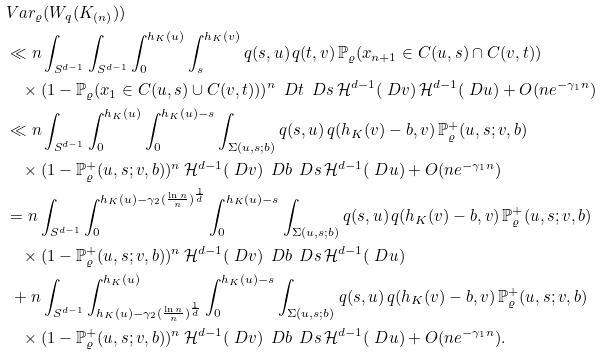<formula> <loc_0><loc_0><loc_500><loc_500>& \ V a r _ { \varrho } ( W _ { q } ( K _ { ( n ) } ) ) \\ & \ \ll n \int _ { S ^ { d - 1 } } \int _ { S ^ { d - 1 } } \int _ { 0 } ^ { h _ { K } ( u ) } \int _ { s } ^ { h _ { K } ( v ) } q ( s , u ) \, q ( t , v ) \, \mathbb { P } _ { \varrho } ( x _ { n + 1 } \in C ( u , s ) \cap C ( v , t ) ) \\ & \ \quad \times ( 1 - \mathbb { P } _ { \varrho } ( x _ { 1 } \in C ( u , s ) \cup C ( v , t ) ) ) ^ { n } \, \ D t \, \ D s \, \mathcal { H } ^ { d - 1 } ( \ D v ) \, \mathcal { H } ^ { d - 1 } ( \ D u ) + O ( n e ^ { - \gamma _ { 1 } n } ) \\ & \ \ll n \int _ { S ^ { d - 1 } } \int _ { 0 } ^ { h _ { K } ( u ) } \int _ { 0 } ^ { h _ { K } ( u ) - s } \int _ { \Sigma ( u , s ; b ) } q ( s , u ) \, q ( h _ { K } ( v ) - b , v ) \, \mathbb { P } _ { \varrho } ^ { + } ( u , s ; v , b ) \\ & \ \quad \times ( 1 - \mathbb { P } _ { \varrho } ^ { + } ( u , s ; v , b ) ) ^ { n } \, \mathcal { H } ^ { d - 1 } ( \ D v ) \, \ D b \, \ D s \, \mathcal { H } ^ { d - 1 } ( \ D u ) + O ( n e ^ { - \gamma _ { 1 } n } ) \\ & \ = n \int _ { S ^ { d - 1 } } \int _ { 0 } ^ { h _ { K } ( u ) - \gamma _ { 2 } ( \frac { \ln n } { n } ) ^ { \frac { 1 } { d } } } \int _ { 0 } ^ { h _ { K } ( u ) - s } \int _ { \Sigma ( u , s ; b ) } q ( s , u ) \, q ( h _ { K } ( v ) - b , v ) \, \mathbb { P } _ { \varrho } ^ { + } ( u , s ; v , b ) \\ & \ \quad \times ( 1 - \mathbb { P } _ { \varrho } ^ { + } ( u , s ; v , b ) ) ^ { n } \, \mathcal { H } ^ { d - 1 } ( \ D v ) \, \ D b \, \ D s \, \mathcal { H } ^ { d - 1 } ( \ D u ) \\ & \ \ + n \int _ { S ^ { d - 1 } } \int _ { h _ { K } ( u ) - \gamma _ { 2 } ( \frac { \ln n } { n } ) ^ { \frac { 1 } { d } } } ^ { h _ { K } ( u ) } \int _ { 0 } ^ { h _ { K } ( u ) - s } \int _ { \Sigma ( u , s ; b ) } q ( s , u ) \, q ( h _ { K } ( v ) - b , v ) \, \mathbb { P } _ { \varrho } ^ { + } ( u , s ; v , b ) \\ & \ \quad \times ( 1 - \mathbb { P } _ { \varrho } ^ { + } ( u , s ; v , b ) ) ^ { n } \, \mathcal { H } ^ { d - 1 } ( \ D v ) \, \ D b \, \ D s \, \mathcal { H } ^ { d - 1 } ( \ D u ) + O ( n e ^ { - \gamma _ { 1 } n } ) .</formula> 